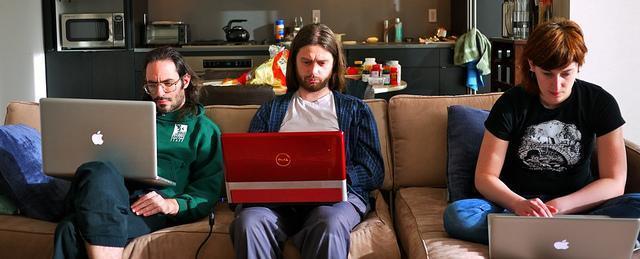How many guys are in the photo?
Give a very brief answer. 2. How many people are in the photo?
Give a very brief answer. 3. How many laptops are visible?
Give a very brief answer. 3. How many horses are there?
Give a very brief answer. 0. 